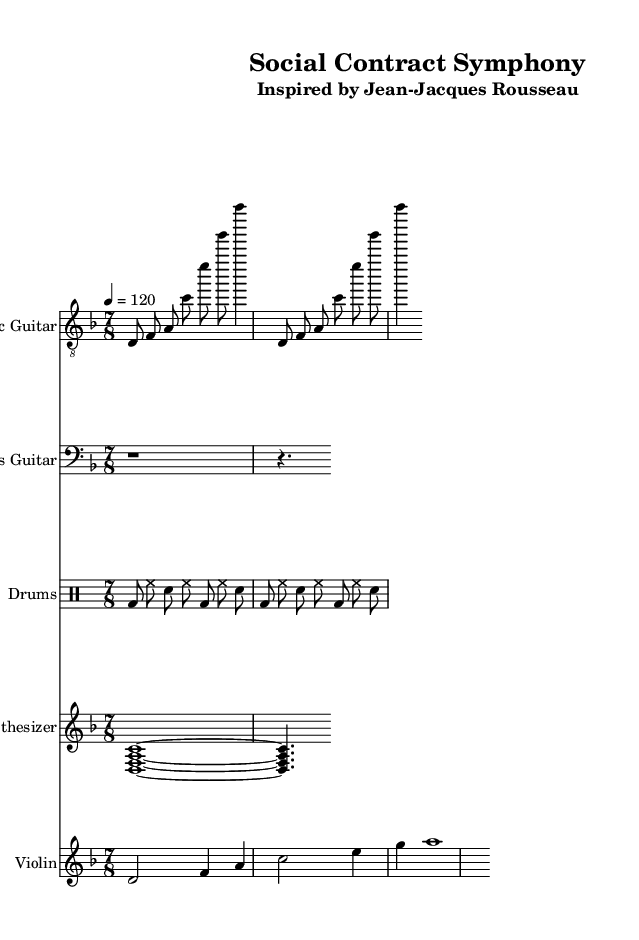What is the key signature of this music? The key signature is indicated by the absence of sharps or flats, meaning it's in D minor which has one flat (B flat). Since there are no additional sharps or flats specified in the music, we confirm that the key signature is D minor.
Answer: D minor What is the time signature of this music? The time signature is clearly indicated as seven eighths (7/8) at the beginning of the score. The notation represents the number of beats in each measure and the type of note that receives one beat, confirming the time signature.
Answer: 7/8 What is the tempo marking of this music? The tempo is marked as 4 equals 120, which means there are 120 beats per minute. This is a common way to indicate the speed of the music, and it is clearly stated at the beginning of the score.
Answer: 120 What instrument plays the main melody in this composition? The melody is primarily presented by the violin staff, which indicates the instrument as "Violin" and contains the most prominent melodic line in the score.
Answer: Violin Which section features a repeated pattern in the drum part? The drum section has a section marked with "repeat unfold 2", indicating that a specific rhythm pattern is repeated two times. This repetition is a common feature in rock music, emphasizing the rhythmic drive.
Answer: Drum How many instruments are used in this sheet music? There are five distinct staves in the score, each labeled for a different instrument: Electric Guitar, Bass Guitar, Drums, Synthesizer, and Violin. Counting these, we can definitively say that five instruments are involved in the composition.
Answer: Five What is the main theme of this composition? The title "Social Contract Symphony" suggests that the overarching theme is likely based on the political philosophy of Jean-Jacques Rousseau regarding social contract theory, which connects the music's inspiration to political thought.
Answer: Social Contract 